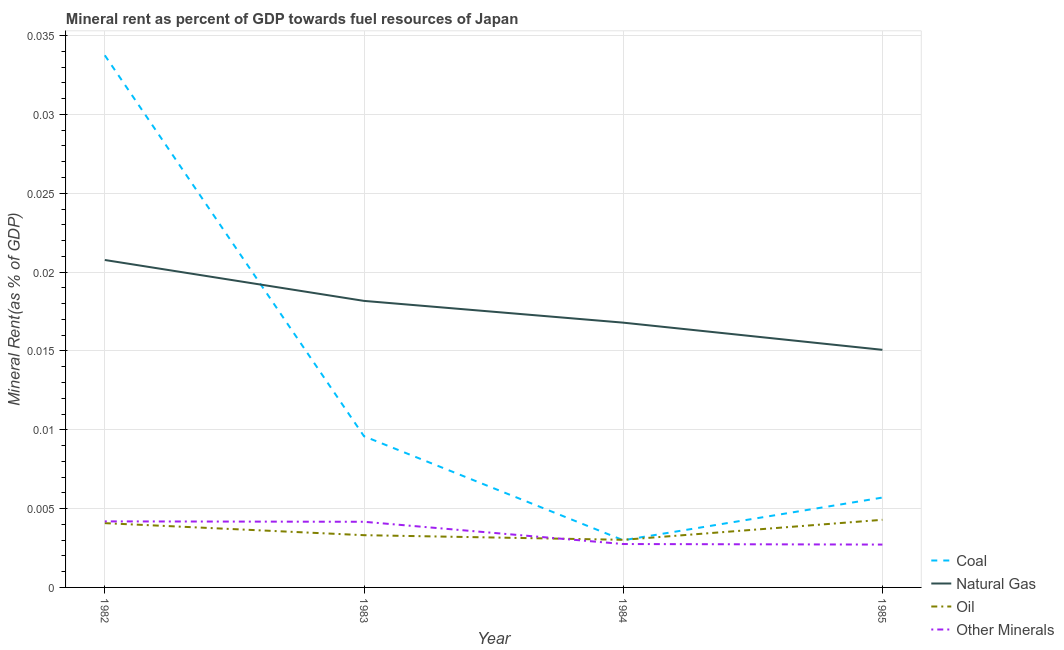Is the number of lines equal to the number of legend labels?
Your answer should be compact. Yes. What is the coal rent in 1982?
Make the answer very short. 0.03. Across all years, what is the maximum oil rent?
Your response must be concise. 0. Across all years, what is the minimum oil rent?
Your answer should be very brief. 0. What is the total natural gas rent in the graph?
Make the answer very short. 0.07. What is the difference between the coal rent in 1982 and that in 1983?
Offer a terse response. 0.02. What is the difference between the natural gas rent in 1984 and the coal rent in 1983?
Provide a short and direct response. 0.01. What is the average natural gas rent per year?
Ensure brevity in your answer.  0.02. In the year 1982, what is the difference between the  rent of other minerals and coal rent?
Offer a terse response. -0.03. What is the ratio of the natural gas rent in 1983 to that in 1985?
Offer a very short reply. 1.21. Is the coal rent in 1984 less than that in 1985?
Your response must be concise. Yes. Is the difference between the natural gas rent in 1982 and 1983 greater than the difference between the oil rent in 1982 and 1983?
Provide a short and direct response. Yes. What is the difference between the highest and the second highest coal rent?
Your answer should be compact. 0.02. What is the difference between the highest and the lowest natural gas rent?
Your answer should be compact. 0.01. In how many years, is the  rent of other minerals greater than the average  rent of other minerals taken over all years?
Ensure brevity in your answer.  2. Is the sum of the coal rent in 1982 and 1984 greater than the maximum natural gas rent across all years?
Give a very brief answer. Yes. Does the  rent of other minerals monotonically increase over the years?
Your answer should be compact. No. Is the oil rent strictly less than the  rent of other minerals over the years?
Make the answer very short. No. What is the difference between two consecutive major ticks on the Y-axis?
Your response must be concise. 0.01. Are the values on the major ticks of Y-axis written in scientific E-notation?
Your response must be concise. No. Does the graph contain any zero values?
Offer a terse response. No. How are the legend labels stacked?
Provide a succinct answer. Vertical. What is the title of the graph?
Offer a very short reply. Mineral rent as percent of GDP towards fuel resources of Japan. What is the label or title of the Y-axis?
Provide a short and direct response. Mineral Rent(as % of GDP). What is the Mineral Rent(as % of GDP) in Coal in 1982?
Offer a terse response. 0.03. What is the Mineral Rent(as % of GDP) in Natural Gas in 1982?
Offer a terse response. 0.02. What is the Mineral Rent(as % of GDP) of Oil in 1982?
Your answer should be very brief. 0. What is the Mineral Rent(as % of GDP) of Other Minerals in 1982?
Your response must be concise. 0. What is the Mineral Rent(as % of GDP) in Coal in 1983?
Your response must be concise. 0.01. What is the Mineral Rent(as % of GDP) of Natural Gas in 1983?
Your answer should be very brief. 0.02. What is the Mineral Rent(as % of GDP) in Oil in 1983?
Your answer should be very brief. 0. What is the Mineral Rent(as % of GDP) in Other Minerals in 1983?
Your answer should be very brief. 0. What is the Mineral Rent(as % of GDP) of Coal in 1984?
Your answer should be compact. 0. What is the Mineral Rent(as % of GDP) in Natural Gas in 1984?
Provide a short and direct response. 0.02. What is the Mineral Rent(as % of GDP) in Oil in 1984?
Provide a short and direct response. 0. What is the Mineral Rent(as % of GDP) in Other Minerals in 1984?
Offer a very short reply. 0. What is the Mineral Rent(as % of GDP) of Coal in 1985?
Your answer should be very brief. 0.01. What is the Mineral Rent(as % of GDP) of Natural Gas in 1985?
Offer a terse response. 0.02. What is the Mineral Rent(as % of GDP) in Oil in 1985?
Make the answer very short. 0. What is the Mineral Rent(as % of GDP) of Other Minerals in 1985?
Give a very brief answer. 0. Across all years, what is the maximum Mineral Rent(as % of GDP) in Coal?
Your response must be concise. 0.03. Across all years, what is the maximum Mineral Rent(as % of GDP) in Natural Gas?
Make the answer very short. 0.02. Across all years, what is the maximum Mineral Rent(as % of GDP) in Oil?
Provide a short and direct response. 0. Across all years, what is the maximum Mineral Rent(as % of GDP) in Other Minerals?
Ensure brevity in your answer.  0. Across all years, what is the minimum Mineral Rent(as % of GDP) of Coal?
Offer a very short reply. 0. Across all years, what is the minimum Mineral Rent(as % of GDP) in Natural Gas?
Provide a short and direct response. 0.02. Across all years, what is the minimum Mineral Rent(as % of GDP) in Oil?
Your response must be concise. 0. Across all years, what is the minimum Mineral Rent(as % of GDP) in Other Minerals?
Give a very brief answer. 0. What is the total Mineral Rent(as % of GDP) in Coal in the graph?
Ensure brevity in your answer.  0.05. What is the total Mineral Rent(as % of GDP) in Natural Gas in the graph?
Your answer should be compact. 0.07. What is the total Mineral Rent(as % of GDP) in Oil in the graph?
Keep it short and to the point. 0.01. What is the total Mineral Rent(as % of GDP) of Other Minerals in the graph?
Keep it short and to the point. 0.01. What is the difference between the Mineral Rent(as % of GDP) of Coal in 1982 and that in 1983?
Provide a succinct answer. 0.02. What is the difference between the Mineral Rent(as % of GDP) in Natural Gas in 1982 and that in 1983?
Your answer should be compact. 0. What is the difference between the Mineral Rent(as % of GDP) in Oil in 1982 and that in 1983?
Offer a terse response. 0. What is the difference between the Mineral Rent(as % of GDP) of Other Minerals in 1982 and that in 1983?
Your response must be concise. 0. What is the difference between the Mineral Rent(as % of GDP) of Coal in 1982 and that in 1984?
Ensure brevity in your answer.  0.03. What is the difference between the Mineral Rent(as % of GDP) of Natural Gas in 1982 and that in 1984?
Your answer should be compact. 0. What is the difference between the Mineral Rent(as % of GDP) in Oil in 1982 and that in 1984?
Your response must be concise. 0. What is the difference between the Mineral Rent(as % of GDP) of Other Minerals in 1982 and that in 1984?
Offer a very short reply. 0. What is the difference between the Mineral Rent(as % of GDP) in Coal in 1982 and that in 1985?
Provide a succinct answer. 0.03. What is the difference between the Mineral Rent(as % of GDP) of Natural Gas in 1982 and that in 1985?
Your answer should be compact. 0.01. What is the difference between the Mineral Rent(as % of GDP) in Oil in 1982 and that in 1985?
Offer a very short reply. -0. What is the difference between the Mineral Rent(as % of GDP) in Other Minerals in 1982 and that in 1985?
Offer a very short reply. 0. What is the difference between the Mineral Rent(as % of GDP) of Coal in 1983 and that in 1984?
Your response must be concise. 0.01. What is the difference between the Mineral Rent(as % of GDP) in Natural Gas in 1983 and that in 1984?
Your answer should be very brief. 0. What is the difference between the Mineral Rent(as % of GDP) in Other Minerals in 1983 and that in 1984?
Provide a short and direct response. 0. What is the difference between the Mineral Rent(as % of GDP) of Coal in 1983 and that in 1985?
Make the answer very short. 0. What is the difference between the Mineral Rent(as % of GDP) of Natural Gas in 1983 and that in 1985?
Give a very brief answer. 0. What is the difference between the Mineral Rent(as % of GDP) of Oil in 1983 and that in 1985?
Keep it short and to the point. -0. What is the difference between the Mineral Rent(as % of GDP) in Other Minerals in 1983 and that in 1985?
Your answer should be compact. 0. What is the difference between the Mineral Rent(as % of GDP) in Coal in 1984 and that in 1985?
Your answer should be very brief. -0. What is the difference between the Mineral Rent(as % of GDP) in Natural Gas in 1984 and that in 1985?
Give a very brief answer. 0. What is the difference between the Mineral Rent(as % of GDP) of Oil in 1984 and that in 1985?
Your answer should be compact. -0. What is the difference between the Mineral Rent(as % of GDP) of Coal in 1982 and the Mineral Rent(as % of GDP) of Natural Gas in 1983?
Keep it short and to the point. 0.02. What is the difference between the Mineral Rent(as % of GDP) of Coal in 1982 and the Mineral Rent(as % of GDP) of Oil in 1983?
Ensure brevity in your answer.  0.03. What is the difference between the Mineral Rent(as % of GDP) in Coal in 1982 and the Mineral Rent(as % of GDP) in Other Minerals in 1983?
Your answer should be compact. 0.03. What is the difference between the Mineral Rent(as % of GDP) in Natural Gas in 1982 and the Mineral Rent(as % of GDP) in Oil in 1983?
Your answer should be compact. 0.02. What is the difference between the Mineral Rent(as % of GDP) in Natural Gas in 1982 and the Mineral Rent(as % of GDP) in Other Minerals in 1983?
Offer a terse response. 0.02. What is the difference between the Mineral Rent(as % of GDP) of Oil in 1982 and the Mineral Rent(as % of GDP) of Other Minerals in 1983?
Offer a very short reply. -0. What is the difference between the Mineral Rent(as % of GDP) of Coal in 1982 and the Mineral Rent(as % of GDP) of Natural Gas in 1984?
Keep it short and to the point. 0.02. What is the difference between the Mineral Rent(as % of GDP) of Coal in 1982 and the Mineral Rent(as % of GDP) of Oil in 1984?
Provide a succinct answer. 0.03. What is the difference between the Mineral Rent(as % of GDP) in Coal in 1982 and the Mineral Rent(as % of GDP) in Other Minerals in 1984?
Make the answer very short. 0.03. What is the difference between the Mineral Rent(as % of GDP) of Natural Gas in 1982 and the Mineral Rent(as % of GDP) of Oil in 1984?
Your answer should be compact. 0.02. What is the difference between the Mineral Rent(as % of GDP) of Natural Gas in 1982 and the Mineral Rent(as % of GDP) of Other Minerals in 1984?
Make the answer very short. 0.02. What is the difference between the Mineral Rent(as % of GDP) of Oil in 1982 and the Mineral Rent(as % of GDP) of Other Minerals in 1984?
Offer a terse response. 0. What is the difference between the Mineral Rent(as % of GDP) of Coal in 1982 and the Mineral Rent(as % of GDP) of Natural Gas in 1985?
Your answer should be compact. 0.02. What is the difference between the Mineral Rent(as % of GDP) in Coal in 1982 and the Mineral Rent(as % of GDP) in Oil in 1985?
Keep it short and to the point. 0.03. What is the difference between the Mineral Rent(as % of GDP) in Coal in 1982 and the Mineral Rent(as % of GDP) in Other Minerals in 1985?
Your answer should be very brief. 0.03. What is the difference between the Mineral Rent(as % of GDP) of Natural Gas in 1982 and the Mineral Rent(as % of GDP) of Oil in 1985?
Your answer should be compact. 0.02. What is the difference between the Mineral Rent(as % of GDP) of Natural Gas in 1982 and the Mineral Rent(as % of GDP) of Other Minerals in 1985?
Your answer should be compact. 0.02. What is the difference between the Mineral Rent(as % of GDP) in Oil in 1982 and the Mineral Rent(as % of GDP) in Other Minerals in 1985?
Your answer should be very brief. 0. What is the difference between the Mineral Rent(as % of GDP) of Coal in 1983 and the Mineral Rent(as % of GDP) of Natural Gas in 1984?
Offer a terse response. -0.01. What is the difference between the Mineral Rent(as % of GDP) in Coal in 1983 and the Mineral Rent(as % of GDP) in Oil in 1984?
Keep it short and to the point. 0.01. What is the difference between the Mineral Rent(as % of GDP) of Coal in 1983 and the Mineral Rent(as % of GDP) of Other Minerals in 1984?
Offer a very short reply. 0.01. What is the difference between the Mineral Rent(as % of GDP) in Natural Gas in 1983 and the Mineral Rent(as % of GDP) in Oil in 1984?
Your answer should be compact. 0.02. What is the difference between the Mineral Rent(as % of GDP) of Natural Gas in 1983 and the Mineral Rent(as % of GDP) of Other Minerals in 1984?
Provide a short and direct response. 0.02. What is the difference between the Mineral Rent(as % of GDP) in Oil in 1983 and the Mineral Rent(as % of GDP) in Other Minerals in 1984?
Your response must be concise. 0. What is the difference between the Mineral Rent(as % of GDP) in Coal in 1983 and the Mineral Rent(as % of GDP) in Natural Gas in 1985?
Your answer should be compact. -0.01. What is the difference between the Mineral Rent(as % of GDP) of Coal in 1983 and the Mineral Rent(as % of GDP) of Oil in 1985?
Ensure brevity in your answer.  0.01. What is the difference between the Mineral Rent(as % of GDP) in Coal in 1983 and the Mineral Rent(as % of GDP) in Other Minerals in 1985?
Provide a short and direct response. 0.01. What is the difference between the Mineral Rent(as % of GDP) of Natural Gas in 1983 and the Mineral Rent(as % of GDP) of Oil in 1985?
Your answer should be very brief. 0.01. What is the difference between the Mineral Rent(as % of GDP) in Natural Gas in 1983 and the Mineral Rent(as % of GDP) in Other Minerals in 1985?
Your response must be concise. 0.02. What is the difference between the Mineral Rent(as % of GDP) in Oil in 1983 and the Mineral Rent(as % of GDP) in Other Minerals in 1985?
Provide a succinct answer. 0. What is the difference between the Mineral Rent(as % of GDP) of Coal in 1984 and the Mineral Rent(as % of GDP) of Natural Gas in 1985?
Keep it short and to the point. -0.01. What is the difference between the Mineral Rent(as % of GDP) of Coal in 1984 and the Mineral Rent(as % of GDP) of Oil in 1985?
Your answer should be very brief. -0. What is the difference between the Mineral Rent(as % of GDP) of Coal in 1984 and the Mineral Rent(as % of GDP) of Other Minerals in 1985?
Offer a terse response. 0. What is the difference between the Mineral Rent(as % of GDP) of Natural Gas in 1984 and the Mineral Rent(as % of GDP) of Oil in 1985?
Your response must be concise. 0.01. What is the difference between the Mineral Rent(as % of GDP) of Natural Gas in 1984 and the Mineral Rent(as % of GDP) of Other Minerals in 1985?
Give a very brief answer. 0.01. What is the difference between the Mineral Rent(as % of GDP) of Oil in 1984 and the Mineral Rent(as % of GDP) of Other Minerals in 1985?
Your response must be concise. 0. What is the average Mineral Rent(as % of GDP) in Coal per year?
Offer a very short reply. 0.01. What is the average Mineral Rent(as % of GDP) in Natural Gas per year?
Make the answer very short. 0.02. What is the average Mineral Rent(as % of GDP) of Oil per year?
Your response must be concise. 0. What is the average Mineral Rent(as % of GDP) in Other Minerals per year?
Give a very brief answer. 0. In the year 1982, what is the difference between the Mineral Rent(as % of GDP) of Coal and Mineral Rent(as % of GDP) of Natural Gas?
Offer a terse response. 0.01. In the year 1982, what is the difference between the Mineral Rent(as % of GDP) of Coal and Mineral Rent(as % of GDP) of Oil?
Offer a terse response. 0.03. In the year 1982, what is the difference between the Mineral Rent(as % of GDP) of Coal and Mineral Rent(as % of GDP) of Other Minerals?
Your answer should be compact. 0.03. In the year 1982, what is the difference between the Mineral Rent(as % of GDP) of Natural Gas and Mineral Rent(as % of GDP) of Oil?
Provide a succinct answer. 0.02. In the year 1982, what is the difference between the Mineral Rent(as % of GDP) of Natural Gas and Mineral Rent(as % of GDP) of Other Minerals?
Offer a terse response. 0.02. In the year 1982, what is the difference between the Mineral Rent(as % of GDP) of Oil and Mineral Rent(as % of GDP) of Other Minerals?
Your answer should be compact. -0. In the year 1983, what is the difference between the Mineral Rent(as % of GDP) in Coal and Mineral Rent(as % of GDP) in Natural Gas?
Provide a short and direct response. -0.01. In the year 1983, what is the difference between the Mineral Rent(as % of GDP) in Coal and Mineral Rent(as % of GDP) in Oil?
Keep it short and to the point. 0.01. In the year 1983, what is the difference between the Mineral Rent(as % of GDP) in Coal and Mineral Rent(as % of GDP) in Other Minerals?
Provide a succinct answer. 0.01. In the year 1983, what is the difference between the Mineral Rent(as % of GDP) of Natural Gas and Mineral Rent(as % of GDP) of Oil?
Keep it short and to the point. 0.01. In the year 1983, what is the difference between the Mineral Rent(as % of GDP) in Natural Gas and Mineral Rent(as % of GDP) in Other Minerals?
Your response must be concise. 0.01. In the year 1983, what is the difference between the Mineral Rent(as % of GDP) of Oil and Mineral Rent(as % of GDP) of Other Minerals?
Offer a terse response. -0. In the year 1984, what is the difference between the Mineral Rent(as % of GDP) in Coal and Mineral Rent(as % of GDP) in Natural Gas?
Your answer should be very brief. -0.01. In the year 1984, what is the difference between the Mineral Rent(as % of GDP) in Coal and Mineral Rent(as % of GDP) in Oil?
Offer a terse response. -0. In the year 1984, what is the difference between the Mineral Rent(as % of GDP) of Natural Gas and Mineral Rent(as % of GDP) of Oil?
Give a very brief answer. 0.01. In the year 1984, what is the difference between the Mineral Rent(as % of GDP) of Natural Gas and Mineral Rent(as % of GDP) of Other Minerals?
Make the answer very short. 0.01. In the year 1985, what is the difference between the Mineral Rent(as % of GDP) of Coal and Mineral Rent(as % of GDP) of Natural Gas?
Provide a short and direct response. -0.01. In the year 1985, what is the difference between the Mineral Rent(as % of GDP) of Coal and Mineral Rent(as % of GDP) of Oil?
Provide a short and direct response. 0. In the year 1985, what is the difference between the Mineral Rent(as % of GDP) in Coal and Mineral Rent(as % of GDP) in Other Minerals?
Your response must be concise. 0. In the year 1985, what is the difference between the Mineral Rent(as % of GDP) of Natural Gas and Mineral Rent(as % of GDP) of Oil?
Provide a succinct answer. 0.01. In the year 1985, what is the difference between the Mineral Rent(as % of GDP) in Natural Gas and Mineral Rent(as % of GDP) in Other Minerals?
Make the answer very short. 0.01. In the year 1985, what is the difference between the Mineral Rent(as % of GDP) of Oil and Mineral Rent(as % of GDP) of Other Minerals?
Give a very brief answer. 0. What is the ratio of the Mineral Rent(as % of GDP) in Coal in 1982 to that in 1983?
Keep it short and to the point. 3.52. What is the ratio of the Mineral Rent(as % of GDP) in Natural Gas in 1982 to that in 1983?
Provide a short and direct response. 1.14. What is the ratio of the Mineral Rent(as % of GDP) of Oil in 1982 to that in 1983?
Make the answer very short. 1.23. What is the ratio of the Mineral Rent(as % of GDP) in Coal in 1982 to that in 1984?
Ensure brevity in your answer.  11.27. What is the ratio of the Mineral Rent(as % of GDP) of Natural Gas in 1982 to that in 1984?
Offer a terse response. 1.24. What is the ratio of the Mineral Rent(as % of GDP) in Oil in 1982 to that in 1984?
Give a very brief answer. 1.35. What is the ratio of the Mineral Rent(as % of GDP) in Other Minerals in 1982 to that in 1984?
Ensure brevity in your answer.  1.52. What is the ratio of the Mineral Rent(as % of GDP) of Coal in 1982 to that in 1985?
Offer a terse response. 5.92. What is the ratio of the Mineral Rent(as % of GDP) of Natural Gas in 1982 to that in 1985?
Your response must be concise. 1.38. What is the ratio of the Mineral Rent(as % of GDP) in Oil in 1982 to that in 1985?
Provide a succinct answer. 0.95. What is the ratio of the Mineral Rent(as % of GDP) of Other Minerals in 1982 to that in 1985?
Provide a succinct answer. 1.54. What is the ratio of the Mineral Rent(as % of GDP) in Coal in 1983 to that in 1984?
Give a very brief answer. 3.2. What is the ratio of the Mineral Rent(as % of GDP) in Natural Gas in 1983 to that in 1984?
Your answer should be very brief. 1.08. What is the ratio of the Mineral Rent(as % of GDP) of Oil in 1983 to that in 1984?
Your response must be concise. 1.1. What is the ratio of the Mineral Rent(as % of GDP) of Other Minerals in 1983 to that in 1984?
Ensure brevity in your answer.  1.51. What is the ratio of the Mineral Rent(as % of GDP) of Coal in 1983 to that in 1985?
Keep it short and to the point. 1.68. What is the ratio of the Mineral Rent(as % of GDP) in Natural Gas in 1983 to that in 1985?
Your answer should be compact. 1.21. What is the ratio of the Mineral Rent(as % of GDP) of Oil in 1983 to that in 1985?
Offer a terse response. 0.77. What is the ratio of the Mineral Rent(as % of GDP) of Other Minerals in 1983 to that in 1985?
Provide a succinct answer. 1.53. What is the ratio of the Mineral Rent(as % of GDP) of Coal in 1984 to that in 1985?
Provide a succinct answer. 0.53. What is the ratio of the Mineral Rent(as % of GDP) of Natural Gas in 1984 to that in 1985?
Provide a short and direct response. 1.11. What is the ratio of the Mineral Rent(as % of GDP) in Oil in 1984 to that in 1985?
Provide a short and direct response. 0.7. What is the ratio of the Mineral Rent(as % of GDP) of Other Minerals in 1984 to that in 1985?
Your answer should be compact. 1.01. What is the difference between the highest and the second highest Mineral Rent(as % of GDP) of Coal?
Your answer should be compact. 0.02. What is the difference between the highest and the second highest Mineral Rent(as % of GDP) of Natural Gas?
Ensure brevity in your answer.  0. What is the difference between the highest and the second highest Mineral Rent(as % of GDP) of Oil?
Your answer should be very brief. 0. What is the difference between the highest and the second highest Mineral Rent(as % of GDP) in Other Minerals?
Offer a terse response. 0. What is the difference between the highest and the lowest Mineral Rent(as % of GDP) of Coal?
Offer a terse response. 0.03. What is the difference between the highest and the lowest Mineral Rent(as % of GDP) of Natural Gas?
Provide a succinct answer. 0.01. What is the difference between the highest and the lowest Mineral Rent(as % of GDP) in Oil?
Your response must be concise. 0. What is the difference between the highest and the lowest Mineral Rent(as % of GDP) of Other Minerals?
Your answer should be very brief. 0. 